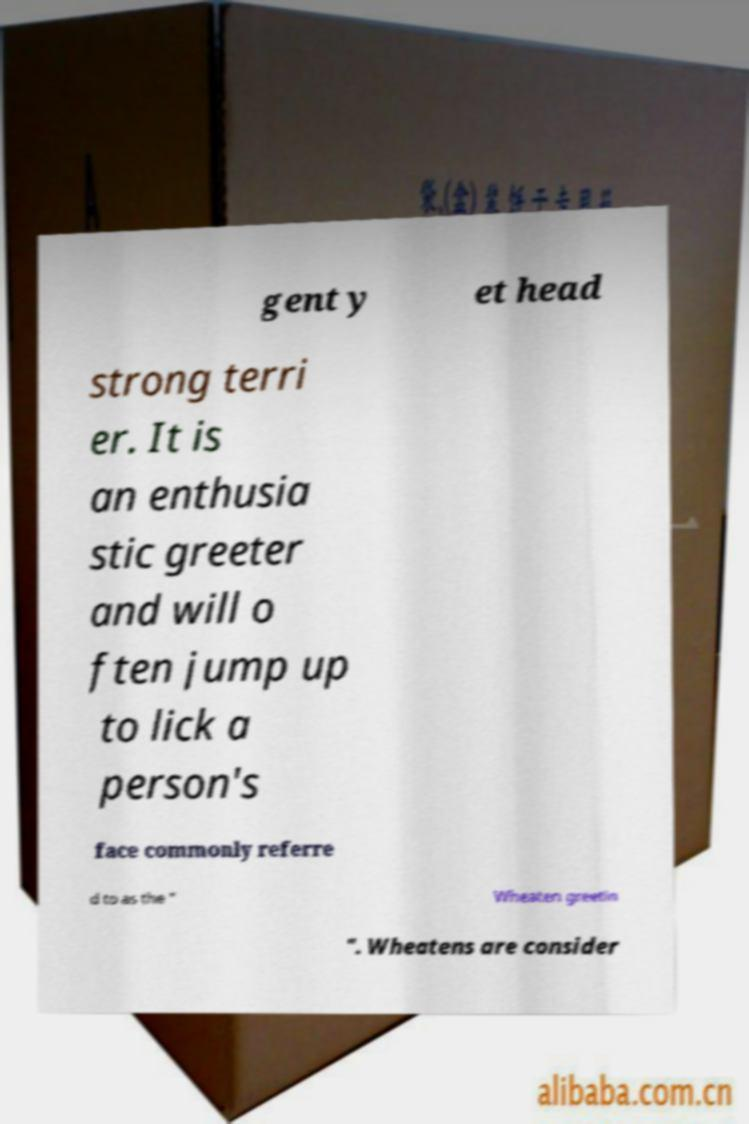For documentation purposes, I need the text within this image transcribed. Could you provide that? gent y et head strong terri er. It is an enthusia stic greeter and will o ften jump up to lick a person's face commonly referre d to as the " Wheaten greetin ". Wheatens are consider 